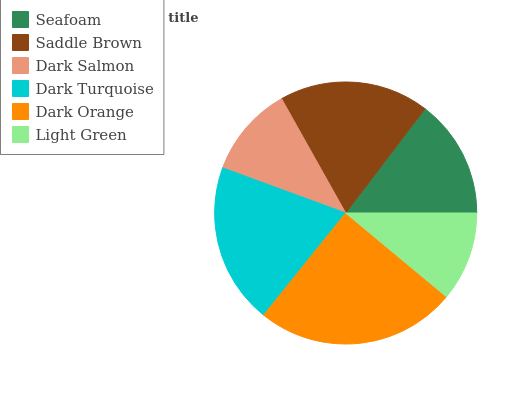Is Light Green the minimum?
Answer yes or no. Yes. Is Dark Orange the maximum?
Answer yes or no. Yes. Is Saddle Brown the minimum?
Answer yes or no. No. Is Saddle Brown the maximum?
Answer yes or no. No. Is Saddle Brown greater than Seafoam?
Answer yes or no. Yes. Is Seafoam less than Saddle Brown?
Answer yes or no. Yes. Is Seafoam greater than Saddle Brown?
Answer yes or no. No. Is Saddle Brown less than Seafoam?
Answer yes or no. No. Is Saddle Brown the high median?
Answer yes or no. Yes. Is Seafoam the low median?
Answer yes or no. Yes. Is Light Green the high median?
Answer yes or no. No. Is Dark Turquoise the low median?
Answer yes or no. No. 